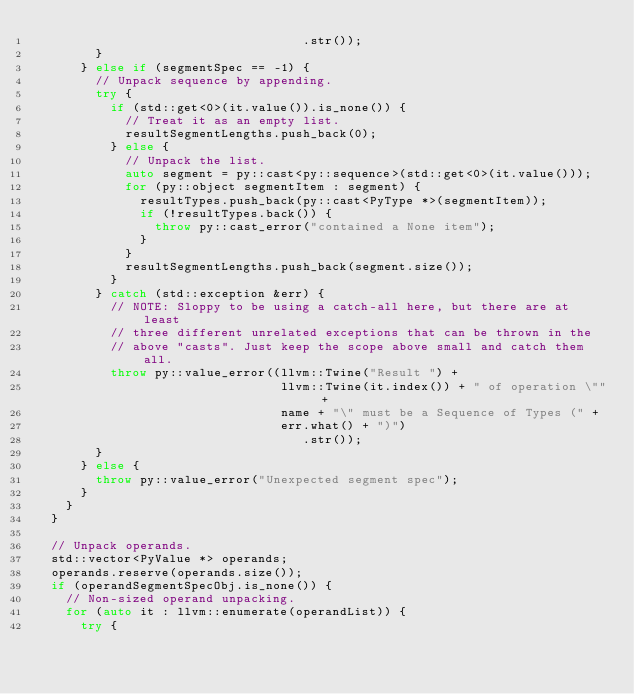Convert code to text. <code><loc_0><loc_0><loc_500><loc_500><_C++_>                                    .str());
        }
      } else if (segmentSpec == -1) {
        // Unpack sequence by appending.
        try {
          if (std::get<0>(it.value()).is_none()) {
            // Treat it as an empty list.
            resultSegmentLengths.push_back(0);
          } else {
            // Unpack the list.
            auto segment = py::cast<py::sequence>(std::get<0>(it.value()));
            for (py::object segmentItem : segment) {
              resultTypes.push_back(py::cast<PyType *>(segmentItem));
              if (!resultTypes.back()) {
                throw py::cast_error("contained a None item");
              }
            }
            resultSegmentLengths.push_back(segment.size());
          }
        } catch (std::exception &err) {
          // NOTE: Sloppy to be using a catch-all here, but there are at least
          // three different unrelated exceptions that can be thrown in the
          // above "casts". Just keep the scope above small and catch them all.
          throw py::value_error((llvm::Twine("Result ") +
                                 llvm::Twine(it.index()) + " of operation \"" +
                                 name + "\" must be a Sequence of Types (" +
                                 err.what() + ")")
                                    .str());
        }
      } else {
        throw py::value_error("Unexpected segment spec");
      }
    }
  }

  // Unpack operands.
  std::vector<PyValue *> operands;
  operands.reserve(operands.size());
  if (operandSegmentSpecObj.is_none()) {
    // Non-sized operand unpacking.
    for (auto it : llvm::enumerate(operandList)) {
      try {</code> 